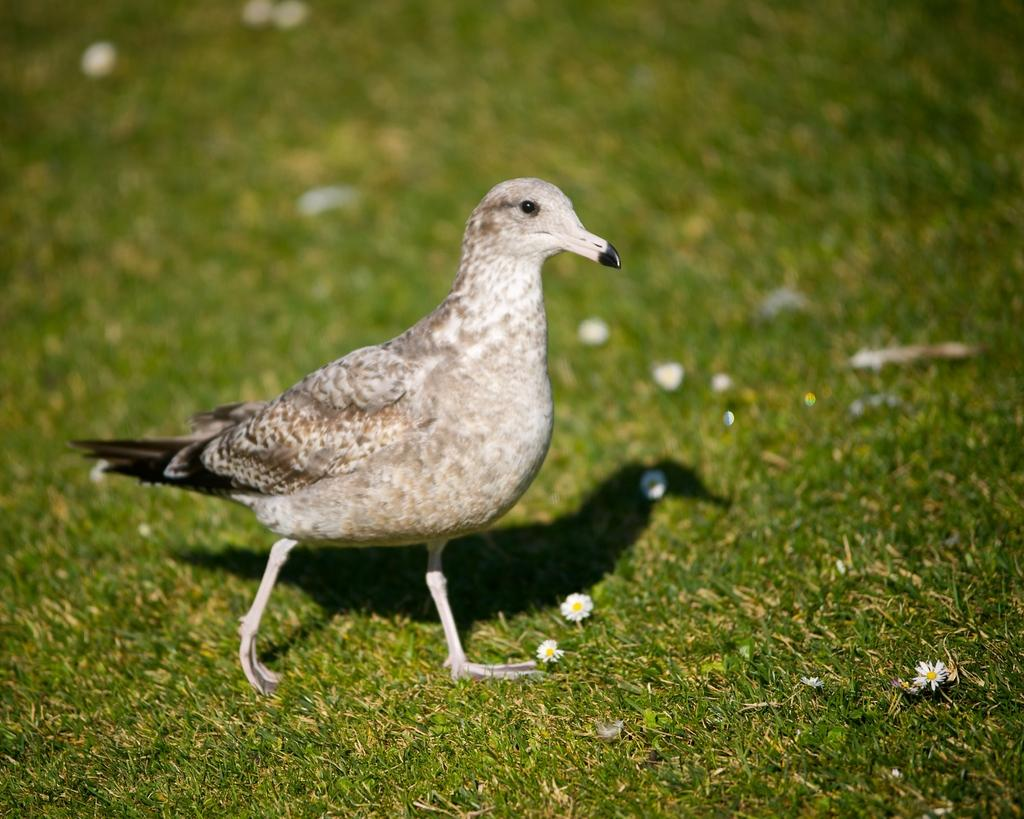What type of surface is visible in the image? There is a grass surface in the image. What animal can be seen in the image? There is a bird in the image. What is the primary color of the bird? The bird is white in color. Are there any other colors on the bird besides white? Yes, the bird has some gray and black coloring in parts. What is the bird's reaction to the roll in the image? There is no roll present in the image, so the bird's reaction cannot be determined. 